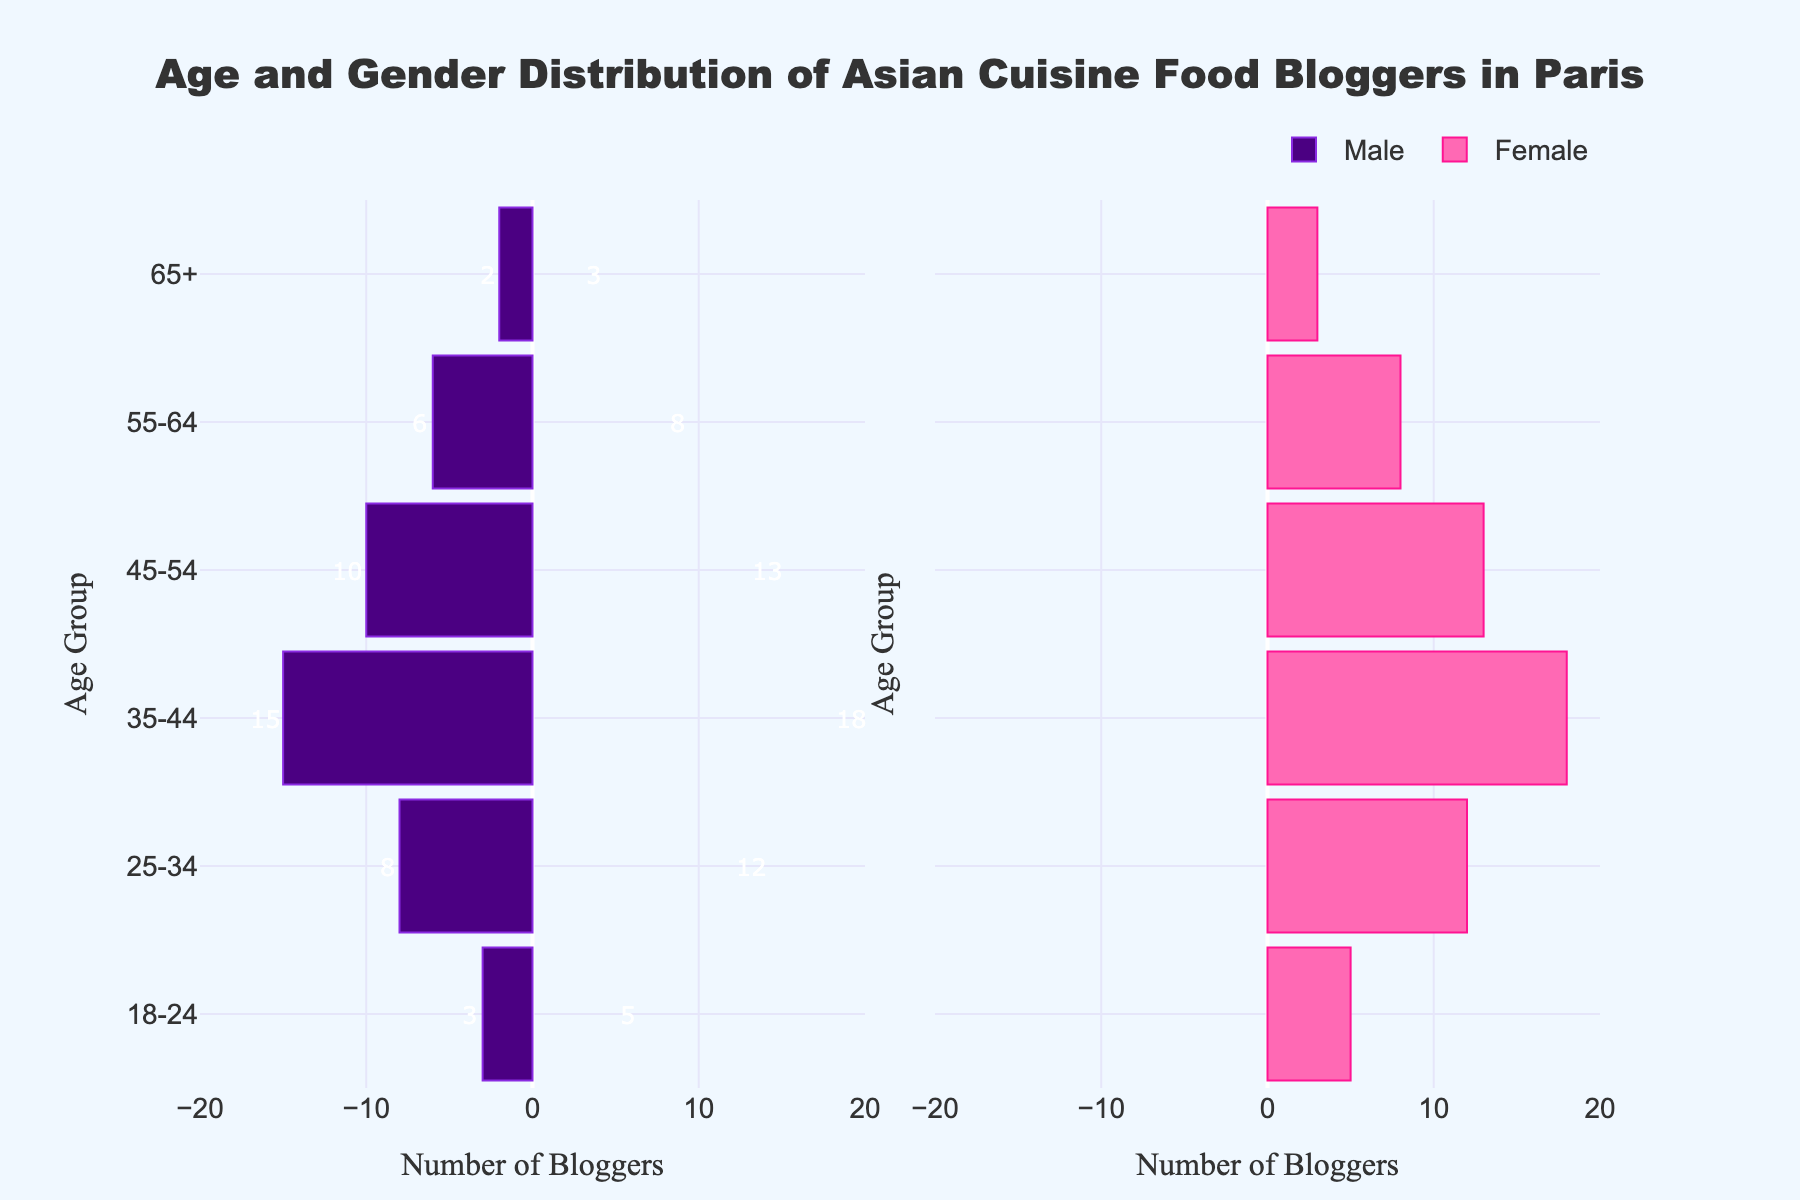What's the title of the figure? The title is generally placed at the top of the figure, usually in a larger or bolder font. In this case, the title is specified as "Age and Gender Distribution of Asian Cuisine Food Bloggers in Paris."
Answer: Age and Gender Distribution of Asian Cuisine Food Bloggers in Paris Which age group has the highest number of female bloggers? The figure shows different age groups with corresponding bars indicating the number of male and female bloggers. The longest bar on the female side corresponds to the 35-44 age group.
Answer: 35-44 How many female bloggers are in the 45-54 age group? Inspect the length of the bar representing the 45-54 age group under the female section. The number labeled next to the bar will indicate the count.
Answer: 13 How many more female bloggers are there than male bloggers in the 35-44 age group? To find this, look at the values of female and male bloggers in this age group. Female bloggers are 18 and male bloggers are 15. Subtract the number of male bloggers from female bloggers to get the difference: 18 - 15 = 3.
Answer: 3 Compare the number of male and female bloggers in the 25-34 age group, who has more? Look at the bar lengths for the 25-34 age group in both the male and female sections. The female bar is longer, indicating more female bloggers. Specifically, there are 12 female bloggers and 8 male bloggers.
Answer: Female What is the total number of bloggers in the 55-64 age group? Sum the number of male and female bloggers in the 55-64 age group. The values are 6 for males and 8 for females: 6 + 8 = 14.
Answer: 14 Which gender has more food bloggers aged 65 and above? Check the lengths of the bars in the 65+ age group for both genders. The female bar is slightly longer than the male bar. Specifically, there are 3 female bloggers and 2 male bloggers.
Answer: Female What is the average number of bloggers in the 18-24 age group? Sum the number of male and female bloggers in this age group: 3 (male) + 5 (female) = 8. Then divide by 2 (for the two genders) to find the average: 8 / 2 = 4.
Answer: 4 In which age group is the gender disparity (difference between males and females) the largest? For each age group, calculate the absolute difference between the number of male and female bloggers. The largest difference is in the 35-44 age group with 18 (female) and 15 (male), resulting in a disparity of 3.
Answer: 35-44 What is the combined total number of food bloggers across all age groups? Sum all the male and female bloggers across each age group: (3+8+15+10+6+2) for males and (5+12+18+13+8+3) for females, which equals 44 males and 59 females. Therefore, the total is 44 + 59 = 103.
Answer: 103 